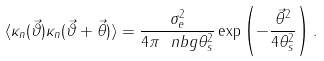Convert formula to latex. <formula><loc_0><loc_0><loc_500><loc_500>\langle \kappa _ { n } ( \vec { \vartheta } ) \kappa _ { n } ( \vec { \vartheta } + \vec { \theta } ) \rangle = \frac { \sigma _ { e } ^ { 2 } } { 4 \pi \ n b g \theta _ { s } ^ { 2 } } \exp \left ( - \frac { \vec { \theta } ^ { 2 } } { 4 \theta _ { s } ^ { 2 } } \right ) .</formula> 